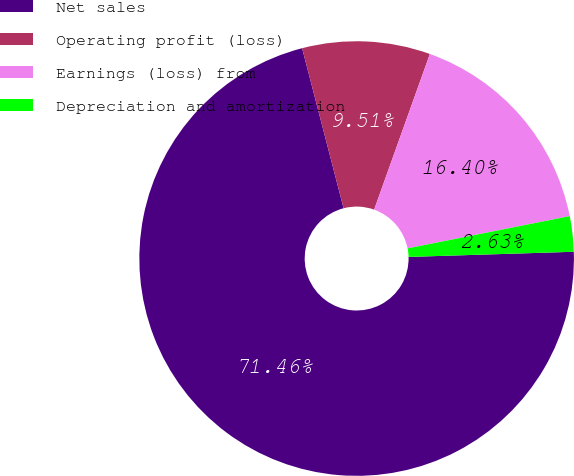Convert chart. <chart><loc_0><loc_0><loc_500><loc_500><pie_chart><fcel>Net sales<fcel>Operating profit (loss)<fcel>Earnings (loss) from<fcel>Depreciation and amortization<nl><fcel>71.46%<fcel>9.51%<fcel>16.4%<fcel>2.63%<nl></chart> 